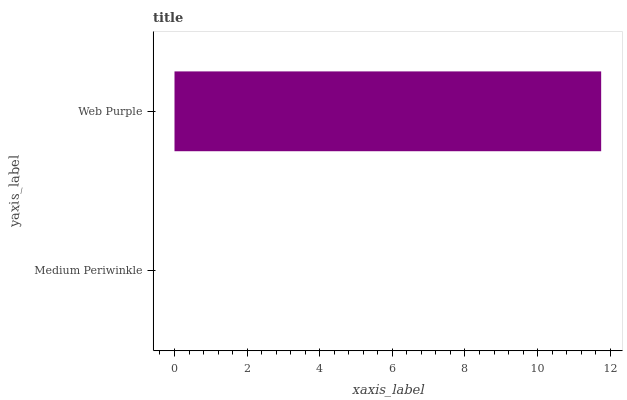Is Medium Periwinkle the minimum?
Answer yes or no. Yes. Is Web Purple the maximum?
Answer yes or no. Yes. Is Web Purple the minimum?
Answer yes or no. No. Is Web Purple greater than Medium Periwinkle?
Answer yes or no. Yes. Is Medium Periwinkle less than Web Purple?
Answer yes or no. Yes. Is Medium Periwinkle greater than Web Purple?
Answer yes or no. No. Is Web Purple less than Medium Periwinkle?
Answer yes or no. No. Is Web Purple the high median?
Answer yes or no. Yes. Is Medium Periwinkle the low median?
Answer yes or no. Yes. Is Medium Periwinkle the high median?
Answer yes or no. No. Is Web Purple the low median?
Answer yes or no. No. 